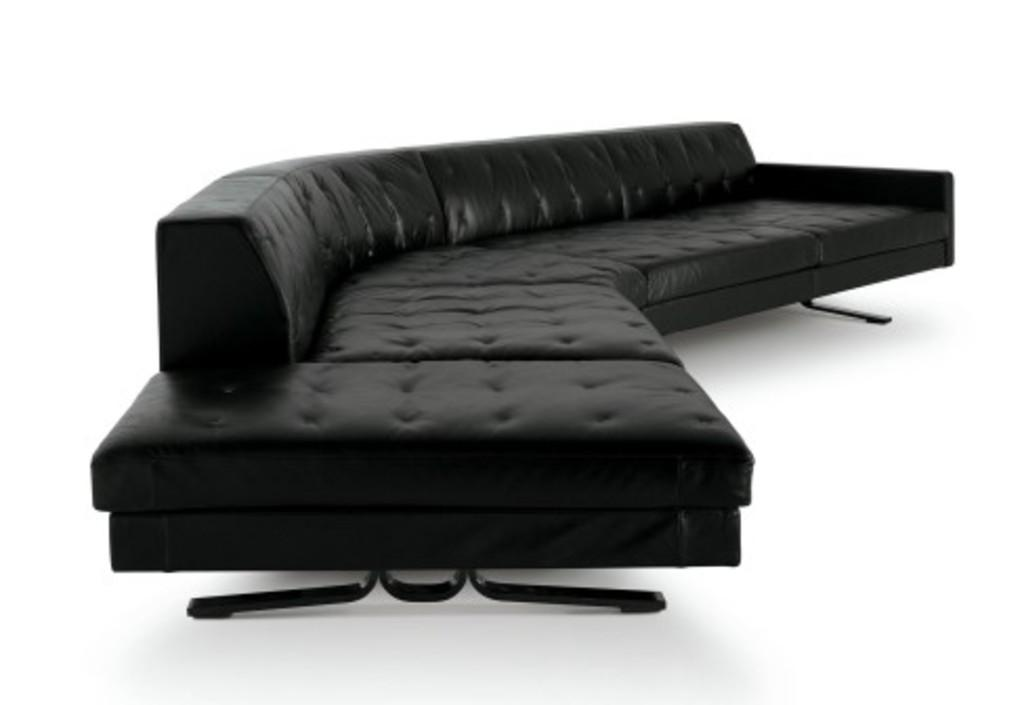What type of furniture is in the image? There is a black color sofa bed in the image. What other object can be seen in the image? There is a metal stand in the image. How many pairs of trousers are hanging on the metal stand in the image? There is no information about trousers or any clothing items in the image; it only features a black color sofa bed and a metal stand. 